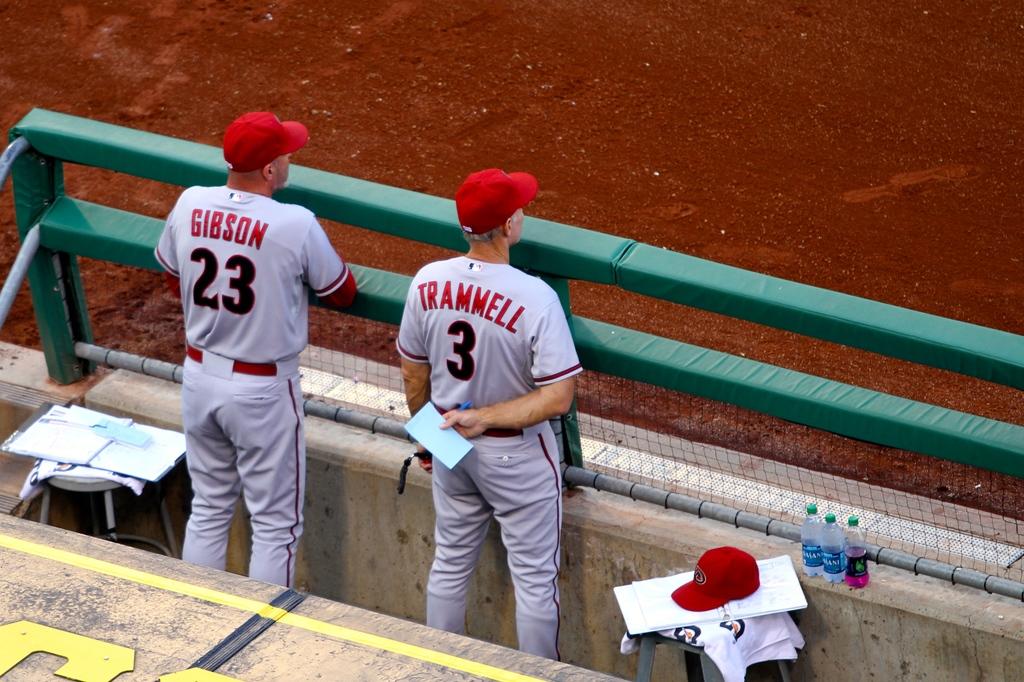What is the man wearing #3's name?
Offer a very short reply. Trammell. Is player 23 out there?
Make the answer very short. Yes. 